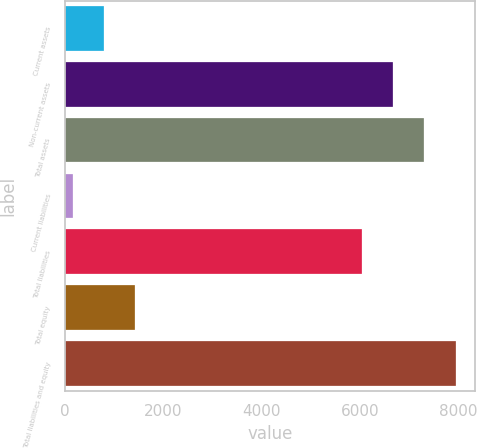Convert chart to OTSL. <chart><loc_0><loc_0><loc_500><loc_500><bar_chart><fcel>Current assets<fcel>Non-current assets<fcel>Total assets<fcel>Current liabilities<fcel>Total liabilities<fcel>Total equity<fcel>Total liabilities and equity<nl><fcel>793.31<fcel>6676.71<fcel>7307.42<fcel>162.6<fcel>6046<fcel>1424.02<fcel>7938.13<nl></chart> 